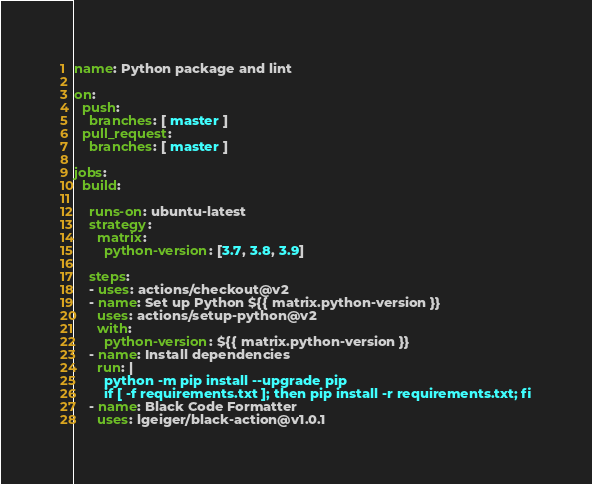<code> <loc_0><loc_0><loc_500><loc_500><_YAML_>name: Python package and lint

on:
  push:
    branches: [ master ]
  pull_request:
    branches: [ master ]

jobs:
  build:

    runs-on: ubuntu-latest
    strategy:
      matrix:
        python-version: [3.7, 3.8, 3.9]

    steps:
    - uses: actions/checkout@v2
    - name: Set up Python ${{ matrix.python-version }}
      uses: actions/setup-python@v2
      with:
        python-version: ${{ matrix.python-version }}
    - name: Install dependencies
      run: |
        python -m pip install --upgrade pip
        if [ -f requirements.txt ]; then pip install -r requirements.txt; fi
    - name: Black Code Formatter
      uses: lgeiger/black-action@v1.0.1

</code> 